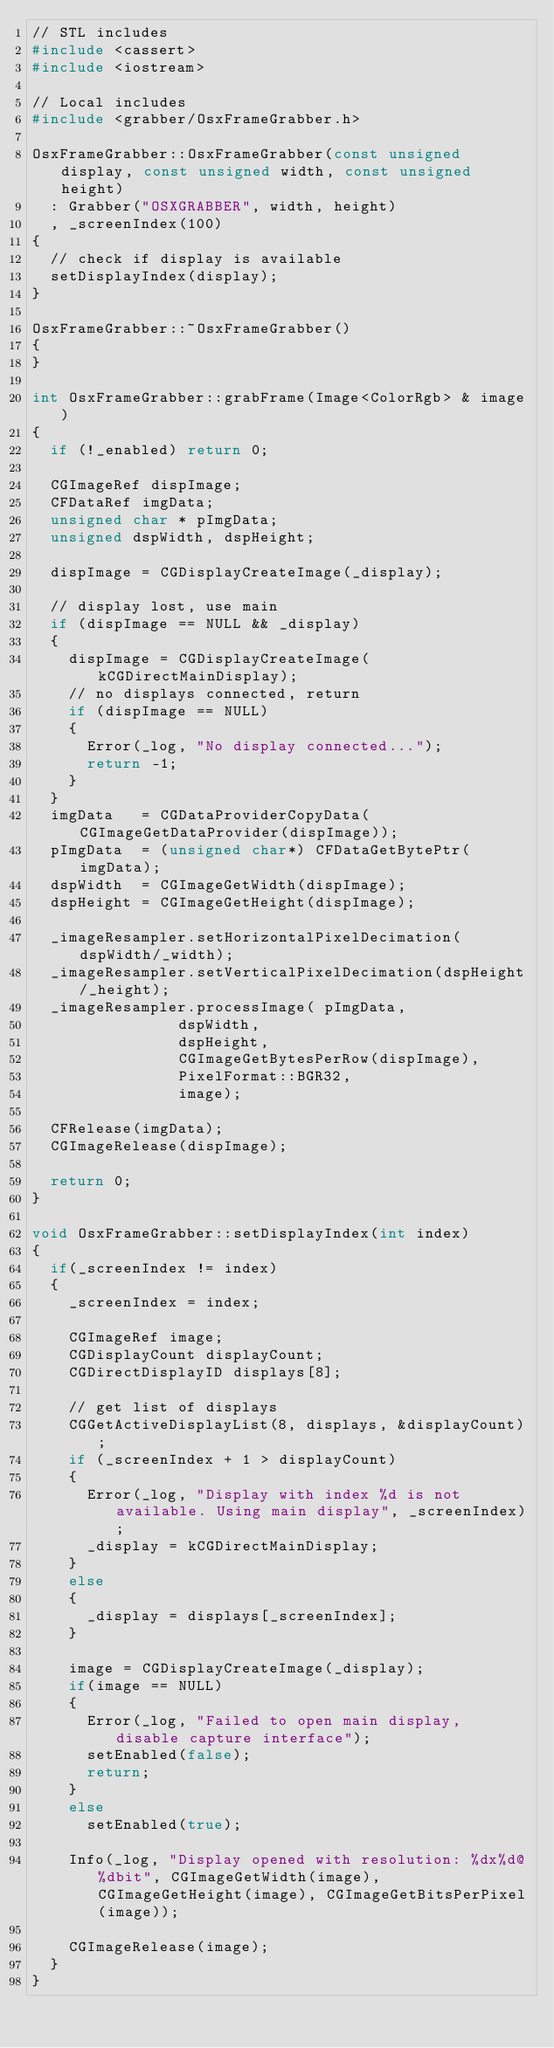<code> <loc_0><loc_0><loc_500><loc_500><_C++_>// STL includes
#include <cassert>
#include <iostream>

// Local includes
#include <grabber/OsxFrameGrabber.h>

OsxFrameGrabber::OsxFrameGrabber(const unsigned display, const unsigned width, const unsigned height)
	: Grabber("OSXGRABBER", width, height)
	, _screenIndex(100)
{
	// check if display is available
	setDisplayIndex(display);
}

OsxFrameGrabber::~OsxFrameGrabber()
{
}

int OsxFrameGrabber::grabFrame(Image<ColorRgb> & image)
{
	if (!_enabled) return 0;

	CGImageRef dispImage;
	CFDataRef imgData;
	unsigned char * pImgData;
	unsigned dspWidth, dspHeight;

	dispImage = CGDisplayCreateImage(_display);

	// display lost, use main
	if (dispImage == NULL && _display)
	{
		dispImage = CGDisplayCreateImage(kCGDirectMainDisplay);
		// no displays connected, return
		if (dispImage == NULL)
		{
			Error(_log, "No display connected...");
			return -1;
		}
	}
	imgData   = CGDataProviderCopyData(CGImageGetDataProvider(dispImage));
	pImgData  = (unsigned char*) CFDataGetBytePtr(imgData);
	dspWidth  = CGImageGetWidth(dispImage);
	dspHeight = CGImageGetHeight(dispImage);

	_imageResampler.setHorizontalPixelDecimation(dspWidth/_width);
	_imageResampler.setVerticalPixelDecimation(dspHeight/_height);
	_imageResampler.processImage( pImgData,
								dspWidth,
								dspHeight,
								CGImageGetBytesPerRow(dispImage),
								PixelFormat::BGR32,
								image);

	CFRelease(imgData);
	CGImageRelease(dispImage);

	return 0;
}

void OsxFrameGrabber::setDisplayIndex(int index)
{
	if(_screenIndex != index)
	{
		_screenIndex = index;

		CGImageRef image;
		CGDisplayCount displayCount;
		CGDirectDisplayID displays[8];

		// get list of displays
		CGGetActiveDisplayList(8, displays, &displayCount);
		if (_screenIndex + 1 > displayCount)
		{
			Error(_log, "Display with index %d is not available. Using main display", _screenIndex);
			_display = kCGDirectMainDisplay;
		}
		else
		{
			_display = displays[_screenIndex];
		}

		image = CGDisplayCreateImage(_display);
		if(image == NULL)
		{
			Error(_log, "Failed to open main display, disable capture interface");
			setEnabled(false);
			return;
		}
		else
			setEnabled(true);

		Info(_log, "Display opened with resolution: %dx%d@%dbit", CGImageGetWidth(image), CGImageGetHeight(image), CGImageGetBitsPerPixel(image));

		CGImageRelease(image);
	}
}
</code> 